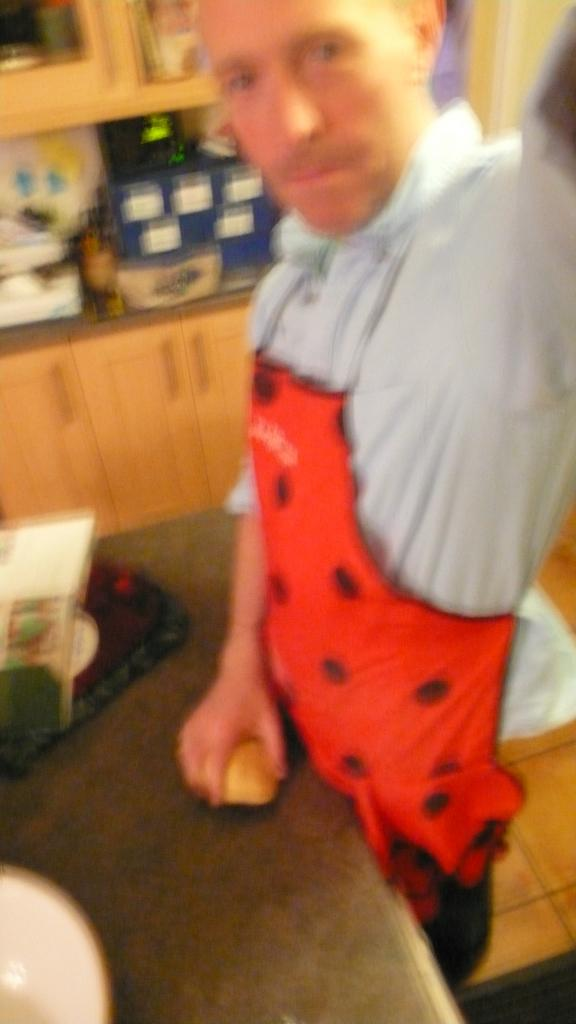What is the man doing in the image? The man is standing in the image. What is the man holding in his hand? The man is holding something in his hand. What can be seen on the table in the image? There is a bowl on a table in the image. What type of furniture is present in the image? There are cupboards in the image. What else can be seen on the countertop in the image? There are items on the countertop in the image. What type of head can be seen on the crib in the image? There is no crib present in the image, so it is not possible to answer that question. 